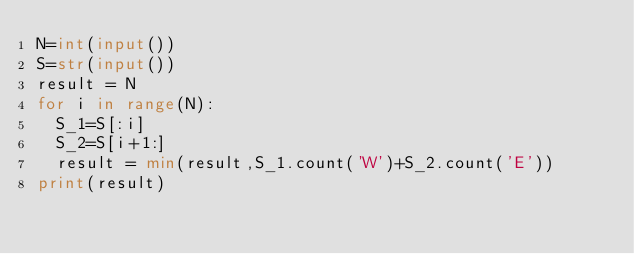<code> <loc_0><loc_0><loc_500><loc_500><_Python_>N=int(input())
S=str(input())
result = N
for i in range(N):
  S_1=S[:i]
  S_2=S[i+1:]
  result = min(result,S_1.count('W')+S_2.count('E'))
print(result)</code> 